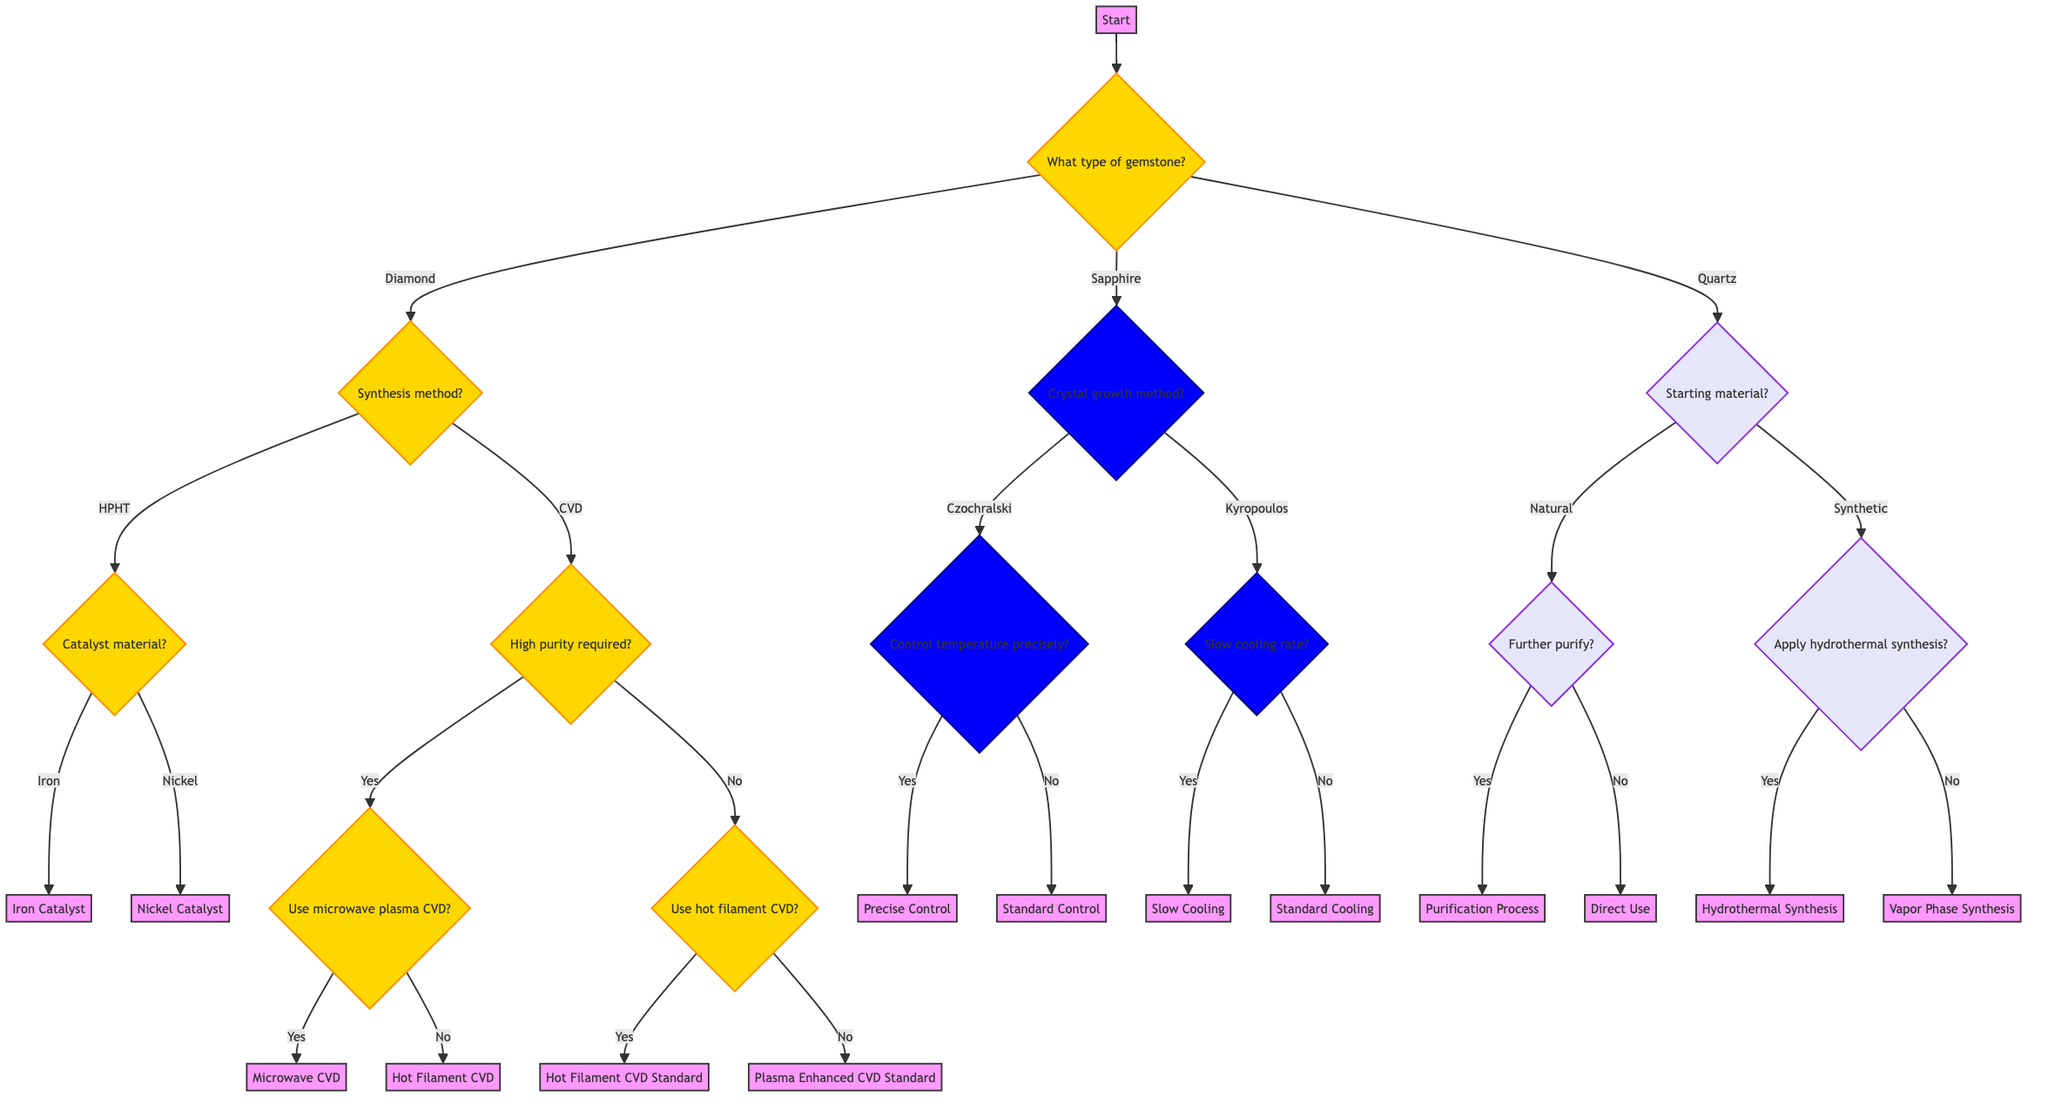What type of gemstone provides the first decision in the diagram? The first decision in the diagram is presented by the question "What type of gemstone is being synthesized?" which offers options for Diamond, Sapphire, or Quartz.
Answer: Diamond, Sapphire, or Quartz How many synthesis methods are available for diamonds? The diagram shows that there are two main synthesis methods for diamonds: High Pressure High Temperature (HPHT) and Chemical Vapor Deposition (CVD), making a total of two.
Answer: 2 What question follows if the CVD method is selected and high purity is required? If the CVD method is chosen and high purity is required, the next question in the flow is "Use microwave plasma CVD?" which evaluates the subsequent process based on this requirement.
Answer: Use microwave plasma CVD? Which crystal growth method chooses the Kyropoulos method? Within the sapphire synthesis section of the diagram, the choice of the Kyropoulos method leads to the question "Slow cooling rate?" which specifically targets conditions associated with that method.
Answer: Slow cooling rate? If the natural starting material is selected for quartz synthesis, what is the next question? After choosing "Natural" as the starting material in quartz synthesis, the next question presented is "Further purify the material?" which assesses if additional purification steps are needed.
Answer: Further purify the material? Which catalyst material options are available after selecting the HPHT method for diamonds? After selecting the HPHT method for diamond synthesis, the available catalyst materials presented are Iron and Nickel, leading to the decision for which catalyst to use.
Answer: Iron or Nickel How does the decision tree progress after selecting the Sapphire Czochralski method? If the Czochralski method is chosen for sapphire synthesis, the next question it leads to is "Control temperature precisely?" which aims to refine the growth conditions further by controlling temperature.
Answer: Control temperature precisely? How many end nodes are present in the diagram? The diagram outlines six end nodes, which signify final decisions or outputs in the synthesis process after traversing through the various questions.
Answer: 6 